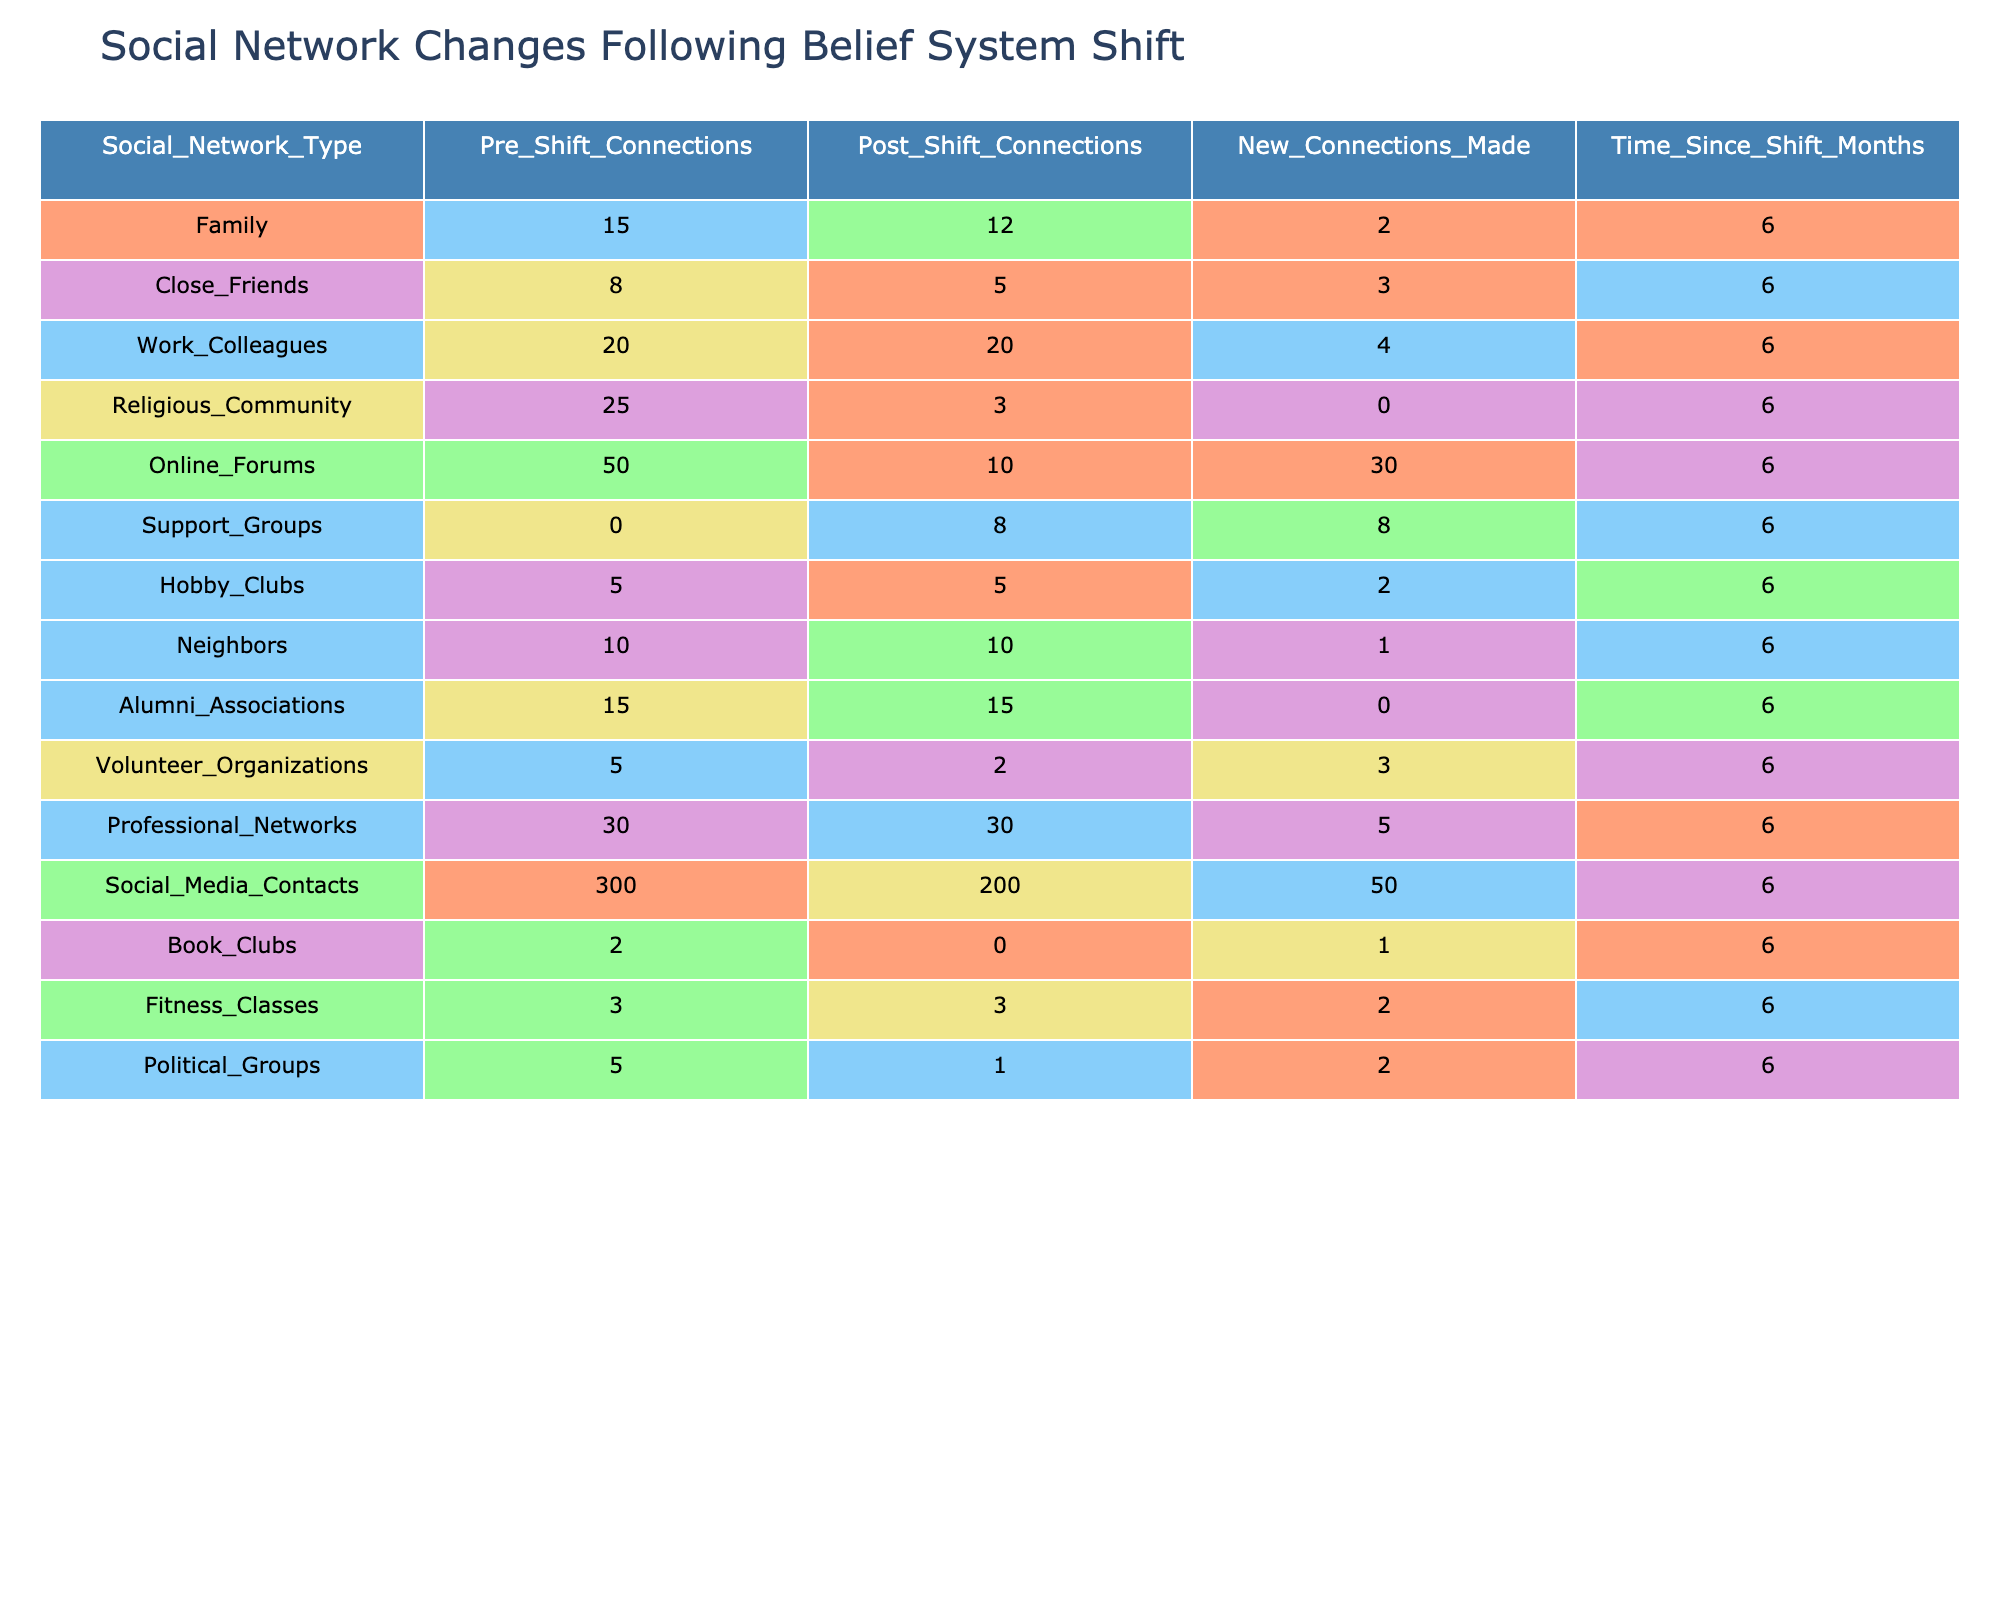What is the total number of connections before the belief system shift across all social networks? To find the total number of connections before the shift, I will sum the values in the "Pre_Shift_Connections" column: 15 + 8 + 20 + 25 + 50 + 0 + 5 + 10 + 15 + 5 + 30 + 300 + 2 + 3 + 5 = 473
Answer: 473 How many new connections were made in the online forums? The number of new connections made in the online forums is directly listed in the "New_Connections_Made" column, which shows a value of 30 for online forums.
Answer: 30 Which social network experienced the most significant drop in connections after the belief system shift? To identify the most significant drop, I will calculate the difference between "Pre_Shift_Connections" and "Post_Shift_Connections" for each social network. The largest drop is seen in the "Religious_Community," where the numbers decreased from 25 to 3, resulting in a drop of 22 connections.
Answer: Religious Community What is the average number of connections made across all social networks post-shift? First, I sum the values in "Post_Shift_Connections" which are: 12 + 5 + 20 + 3 + 10 + 8 + 5 + 10 + 15 + 2 + 30 + 200 + 0 + 3 + 1 = 319. Given there are 15 social networks, I then calculate the average by dividing 319 by 15, resulting in approximately 21.27.
Answer: Approximately 21.27 Is the number of post-shift connections in family social networks greater than the number of connections in support groups? Referring to the "Post_Shift_Connections" for family, it shows 12, while support groups show 8. Since 12 is greater than 8, the statement is true.
Answer: Yes How many social networks remained unchanged in the number of connections after the shift? By examining both "Pre_Shift_Connections" and "Post_Shift_Connections," I see that the values are the same for "Work_Colleagues," "Hobby_Clubs," "Alumni_Associations," and "Professional_Networks." This totals to 4 unchanged social networks.
Answer: 4 What is the total number of connections lost after the belief system shift? I will calculate the total connections lost by summing the difference between "Pre_Shift_Connections" and "Post_Shift_Connections" for each network: (15-12) + (8-5) + (20-20) + (25-3) + (50-10) + (0-8) + (5-5) + (10-10) + (15-15) + (5-2) + (30-30) + (300-200) + (2-0) + (3-3) + (5-1) = 274 connections lost in total.
Answer: 274 Which social network had the highest number of new connections made after the shift? The value for new connections made is highest for "Online_Forums" where 30 new connections were recorded, making it the social network with the highest new connections.
Answer: Online Forums How many social networks had more than 10 post-shift connections? By checking the "Post_Shift_Connections" for each social network, I see that "Work_Colleagues" (20), "Professional_Networks" (30), and "Social_Media_Contacts" (200) all have more than 10 connections, which makes a total of 4 social networks.
Answer: 4 What proportion of the total pre-shift connections does the religious community represent? First, I find the total pre-shift connections, which is 473. The religious community had 25 pre-shift connections. To find the proportion, I calculate 25/473, which is approximately 0.0529 or about 5.29%.
Answer: Approximately 5.29% 